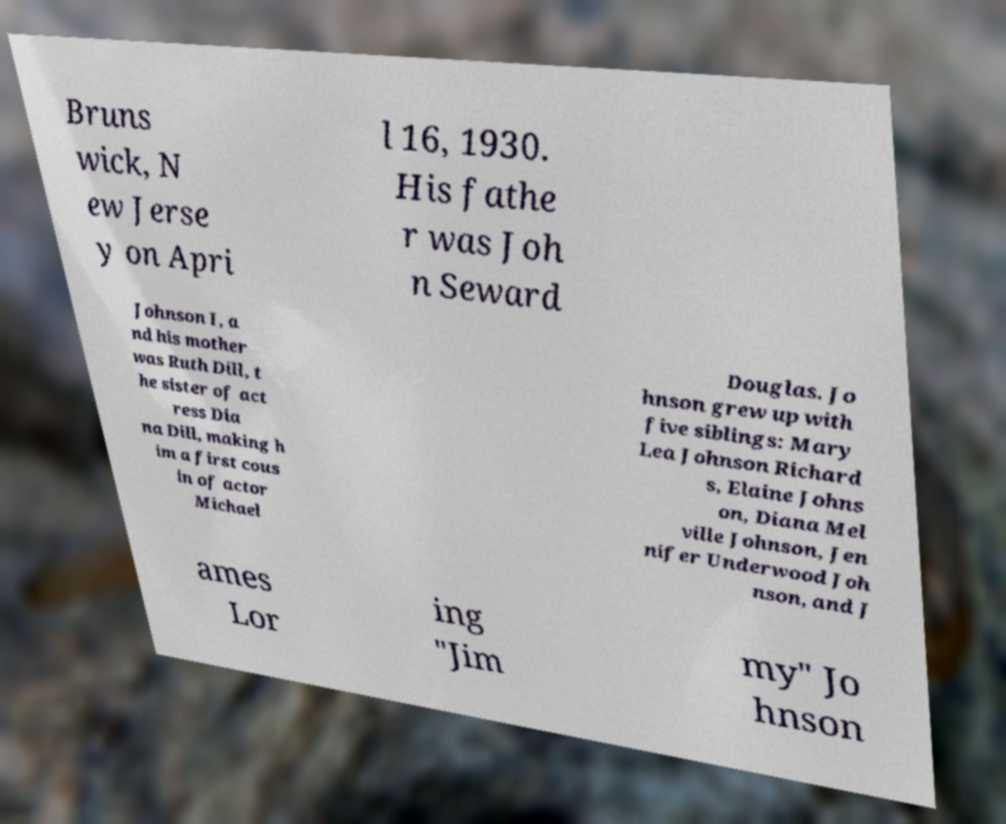Could you assist in decoding the text presented in this image and type it out clearly? Bruns wick, N ew Jerse y on Apri l 16, 1930. His fathe r was Joh n Seward Johnson I, a nd his mother was Ruth Dill, t he sister of act ress Dia na Dill, making h im a first cous in of actor Michael Douglas. Jo hnson grew up with five siblings: Mary Lea Johnson Richard s, Elaine Johns on, Diana Mel ville Johnson, Jen nifer Underwood Joh nson, and J ames Lor ing "Jim my" Jo hnson 